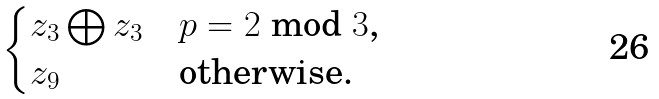<formula> <loc_0><loc_0><loc_500><loc_500>\begin{cases} z _ { 3 } \bigoplus z _ { 3 } & \text {$p = 2$ mod $3$, } \\ z _ { 9 } & \text {otherwise.} \end{cases}</formula> 